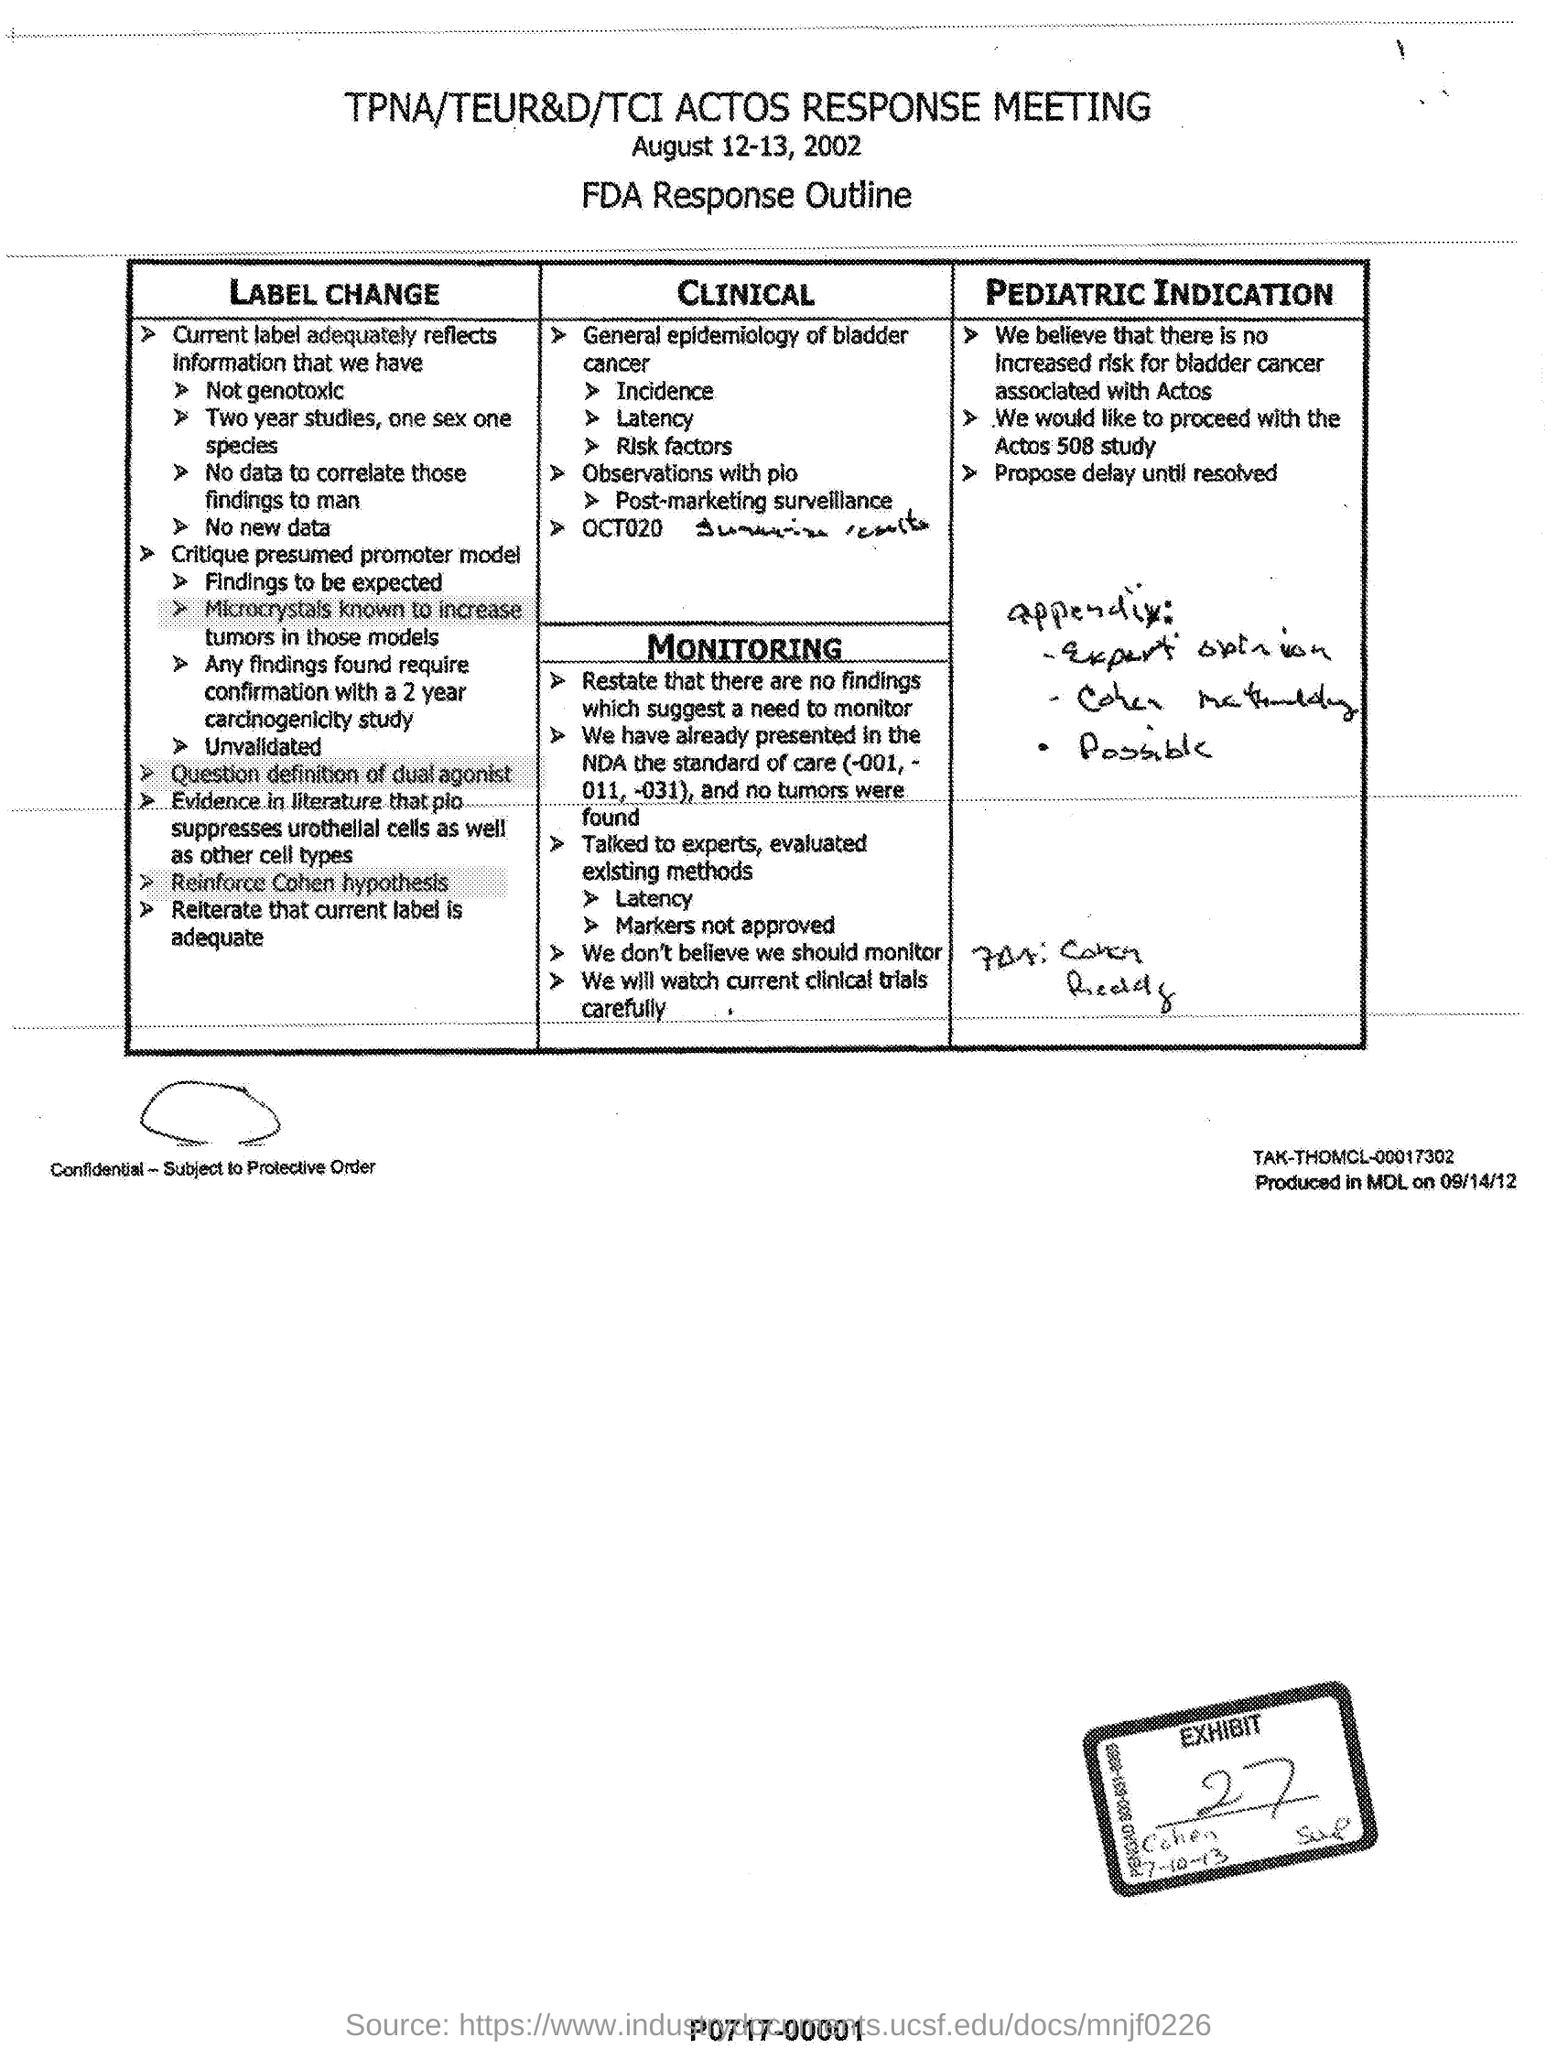List a handful of essential elements in this visual. The heading of the document is "What is the TPNA/TEUR&D/TCI Actos Response Meeting?". The date mentioned is August 12-13, 2002. The heading of the handwritten words in the Pediatric Indication appendix is "What is the heading of the handwritten words in Pediatric Indication appendix? 